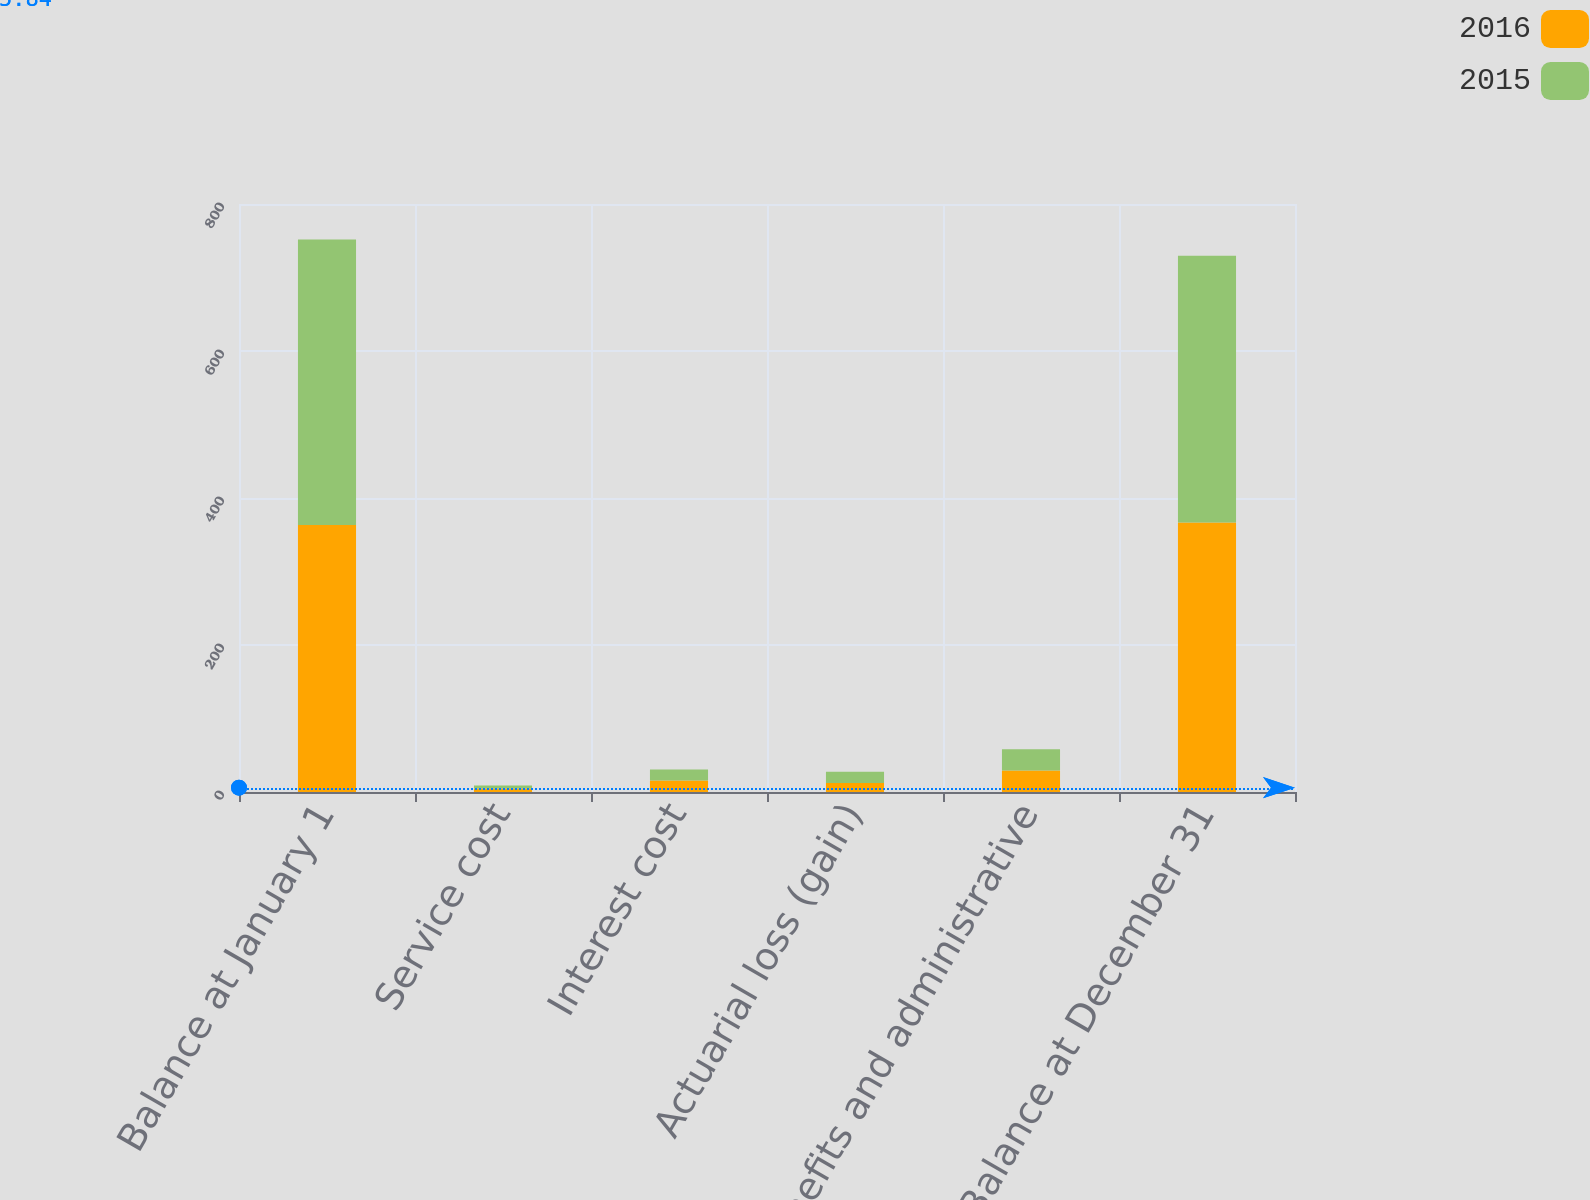Convert chart. <chart><loc_0><loc_0><loc_500><loc_500><stacked_bar_chart><ecel><fcel>Balance at January 1<fcel>Service cost<fcel>Interest cost<fcel>Actuarial loss (gain)<fcel>Benefits and administrative<fcel>Balance at December 31<nl><fcel>2016<fcel>363.1<fcel>4.9<fcel>15.5<fcel>12.1<fcel>29.1<fcel>366.5<nl><fcel>2015<fcel>388.6<fcel>3.9<fcel>15.1<fcel>15.4<fcel>29.1<fcel>363.1<nl></chart> 